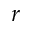<formula> <loc_0><loc_0><loc_500><loc_500>r</formula> 